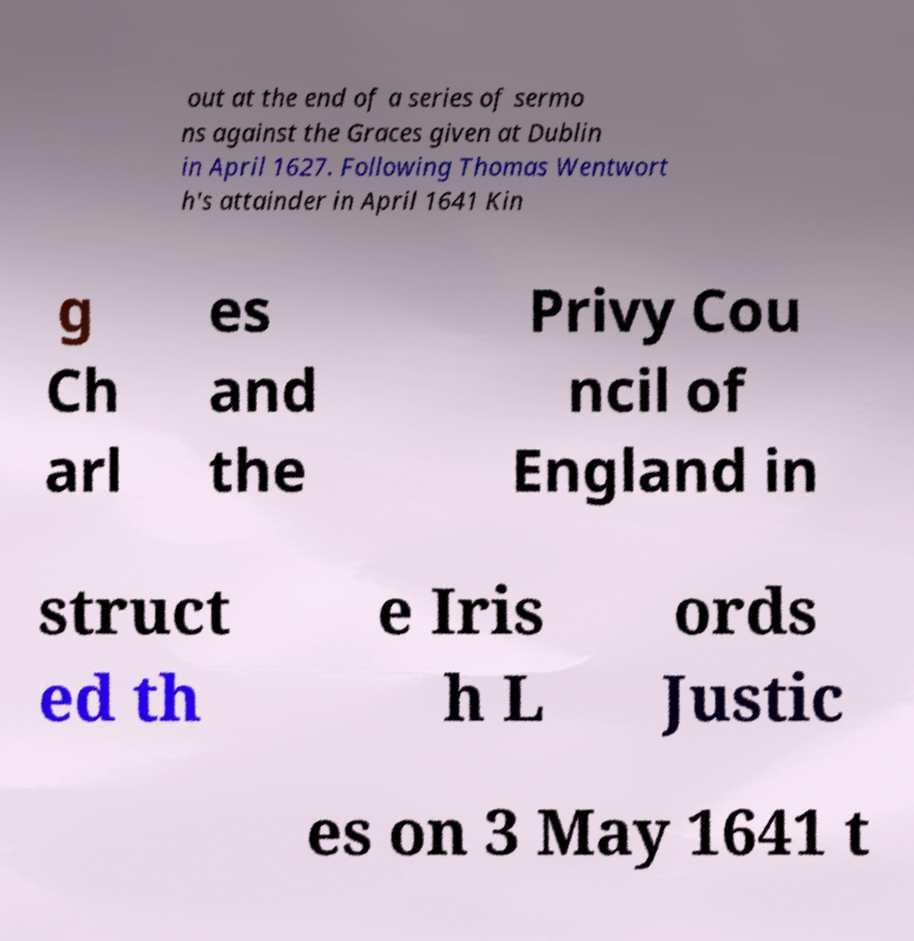What messages or text are displayed in this image? I need them in a readable, typed format. out at the end of a series of sermo ns against the Graces given at Dublin in April 1627. Following Thomas Wentwort h's attainder in April 1641 Kin g Ch arl es and the Privy Cou ncil of England in struct ed th e Iris h L ords Justic es on 3 May 1641 t 